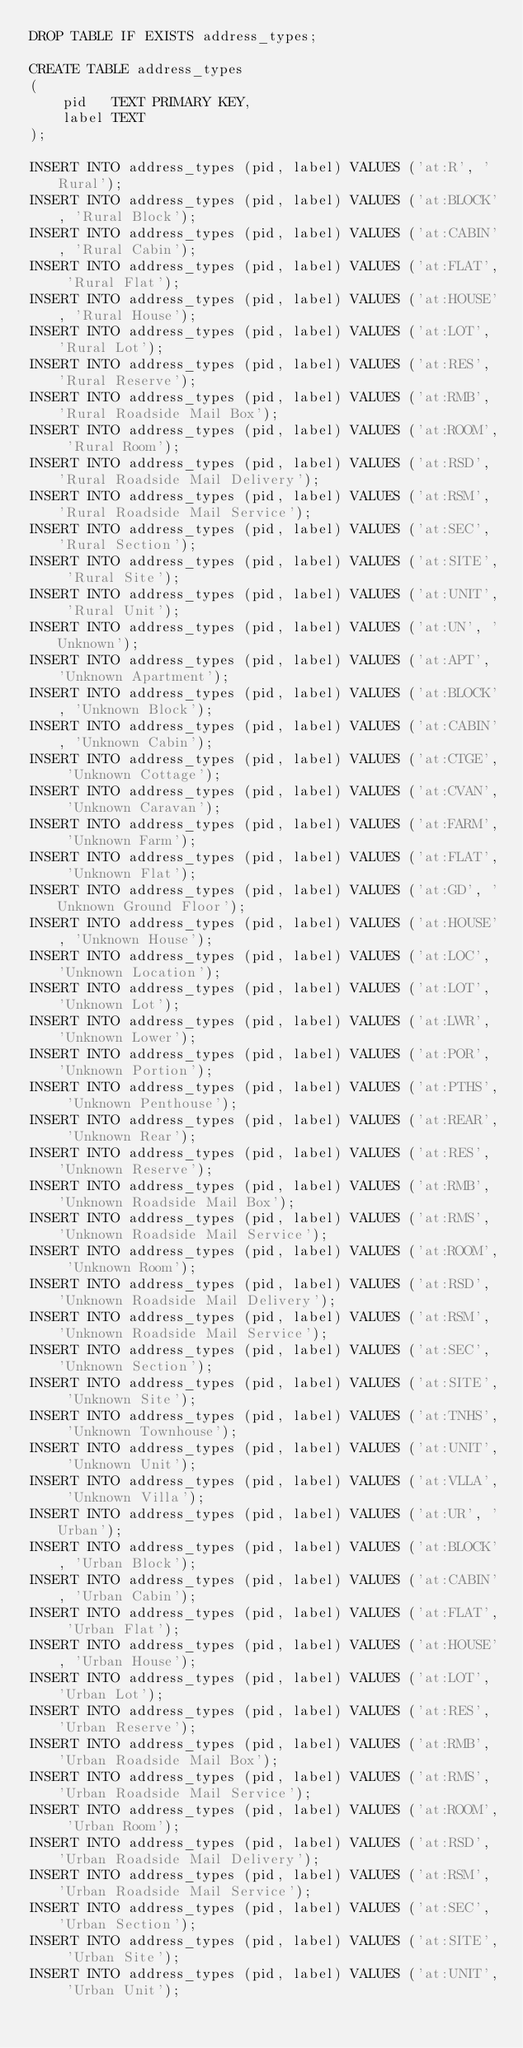Convert code to text. <code><loc_0><loc_0><loc_500><loc_500><_SQL_>DROP TABLE IF EXISTS address_types;

CREATE TABLE address_types
(
    pid   TEXT PRIMARY KEY,
    label TEXT
);

INSERT INTO address_types (pid, label) VALUES ('at:R', 'Rural');
INSERT INTO address_types (pid, label) VALUES ('at:BLOCK', 'Rural Block');
INSERT INTO address_types (pid, label) VALUES ('at:CABIN', 'Rural Cabin');
INSERT INTO address_types (pid, label) VALUES ('at:FLAT', 'Rural Flat');
INSERT INTO address_types (pid, label) VALUES ('at:HOUSE', 'Rural House');
INSERT INTO address_types (pid, label) VALUES ('at:LOT', 'Rural Lot');
INSERT INTO address_types (pid, label) VALUES ('at:RES', 'Rural Reserve');
INSERT INTO address_types (pid, label) VALUES ('at:RMB', 'Rural Roadside Mail Box');
INSERT INTO address_types (pid, label) VALUES ('at:ROOM', 'Rural Room');
INSERT INTO address_types (pid, label) VALUES ('at:RSD', 'Rural Roadside Mail Delivery');
INSERT INTO address_types (pid, label) VALUES ('at:RSM', 'Rural Roadside Mail Service');
INSERT INTO address_types (pid, label) VALUES ('at:SEC', 'Rural Section');
INSERT INTO address_types (pid, label) VALUES ('at:SITE', 'Rural Site');
INSERT INTO address_types (pid, label) VALUES ('at:UNIT', 'Rural Unit');
INSERT INTO address_types (pid, label) VALUES ('at:UN', 'Unknown');
INSERT INTO address_types (pid, label) VALUES ('at:APT', 'Unknown Apartment');
INSERT INTO address_types (pid, label) VALUES ('at:BLOCK', 'Unknown Block');
INSERT INTO address_types (pid, label) VALUES ('at:CABIN', 'Unknown Cabin');
INSERT INTO address_types (pid, label) VALUES ('at:CTGE', 'Unknown Cottage');
INSERT INTO address_types (pid, label) VALUES ('at:CVAN', 'Unknown Caravan');
INSERT INTO address_types (pid, label) VALUES ('at:FARM', 'Unknown Farm');
INSERT INTO address_types (pid, label) VALUES ('at:FLAT', 'Unknown Flat');
INSERT INTO address_types (pid, label) VALUES ('at:GD', 'Unknown Ground Floor');
INSERT INTO address_types (pid, label) VALUES ('at:HOUSE', 'Unknown House');
INSERT INTO address_types (pid, label) VALUES ('at:LOC', 'Unknown Location');
INSERT INTO address_types (pid, label) VALUES ('at:LOT', 'Unknown Lot');
INSERT INTO address_types (pid, label) VALUES ('at:LWR', 'Unknown Lower');
INSERT INTO address_types (pid, label) VALUES ('at:POR', 'Unknown Portion');
INSERT INTO address_types (pid, label) VALUES ('at:PTHS', 'Unknown Penthouse');
INSERT INTO address_types (pid, label) VALUES ('at:REAR', 'Unknown Rear');
INSERT INTO address_types (pid, label) VALUES ('at:RES', 'Unknown Reserve');
INSERT INTO address_types (pid, label) VALUES ('at:RMB', 'Unknown Roadside Mail Box');
INSERT INTO address_types (pid, label) VALUES ('at:RMS', 'Unknown Roadside Mail Service');
INSERT INTO address_types (pid, label) VALUES ('at:ROOM', 'Unknown Room');
INSERT INTO address_types (pid, label) VALUES ('at:RSD', 'Unknown Roadside Mail Delivery');
INSERT INTO address_types (pid, label) VALUES ('at:RSM', 'Unknown Roadside Mail Service');
INSERT INTO address_types (pid, label) VALUES ('at:SEC', 'Unknown Section');
INSERT INTO address_types (pid, label) VALUES ('at:SITE', 'Unknown Site');
INSERT INTO address_types (pid, label) VALUES ('at:TNHS', 'Unknown Townhouse');
INSERT INTO address_types (pid, label) VALUES ('at:UNIT', 'Unknown Unit');
INSERT INTO address_types (pid, label) VALUES ('at:VLLA', 'Unknown Villa');
INSERT INTO address_types (pid, label) VALUES ('at:UR', 'Urban');
INSERT INTO address_types (pid, label) VALUES ('at:BLOCK', 'Urban Block');
INSERT INTO address_types (pid, label) VALUES ('at:CABIN', 'Urban Cabin');
INSERT INTO address_types (pid, label) VALUES ('at:FLAT', 'Urban Flat');
INSERT INTO address_types (pid, label) VALUES ('at:HOUSE', 'Urban House');
INSERT INTO address_types (pid, label) VALUES ('at:LOT', 'Urban Lot');
INSERT INTO address_types (pid, label) VALUES ('at:RES', 'Urban Reserve');
INSERT INTO address_types (pid, label) VALUES ('at:RMB', 'Urban Roadside Mail Box');
INSERT INTO address_types (pid, label) VALUES ('at:RMS', 'Urban Roadside Mail Service');
INSERT INTO address_types (pid, label) VALUES ('at:ROOM', 'Urban Room');
INSERT INTO address_types (pid, label) VALUES ('at:RSD', 'Urban Roadside Mail Delivery');
INSERT INTO address_types (pid, label) VALUES ('at:RSM', 'Urban Roadside Mail Service');
INSERT INTO address_types (pid, label) VALUES ('at:SEC', 'Urban Section');
INSERT INTO address_types (pid, label) VALUES ('at:SITE', 'Urban Site');
INSERT INTO address_types (pid, label) VALUES ('at:UNIT', 'Urban Unit');</code> 